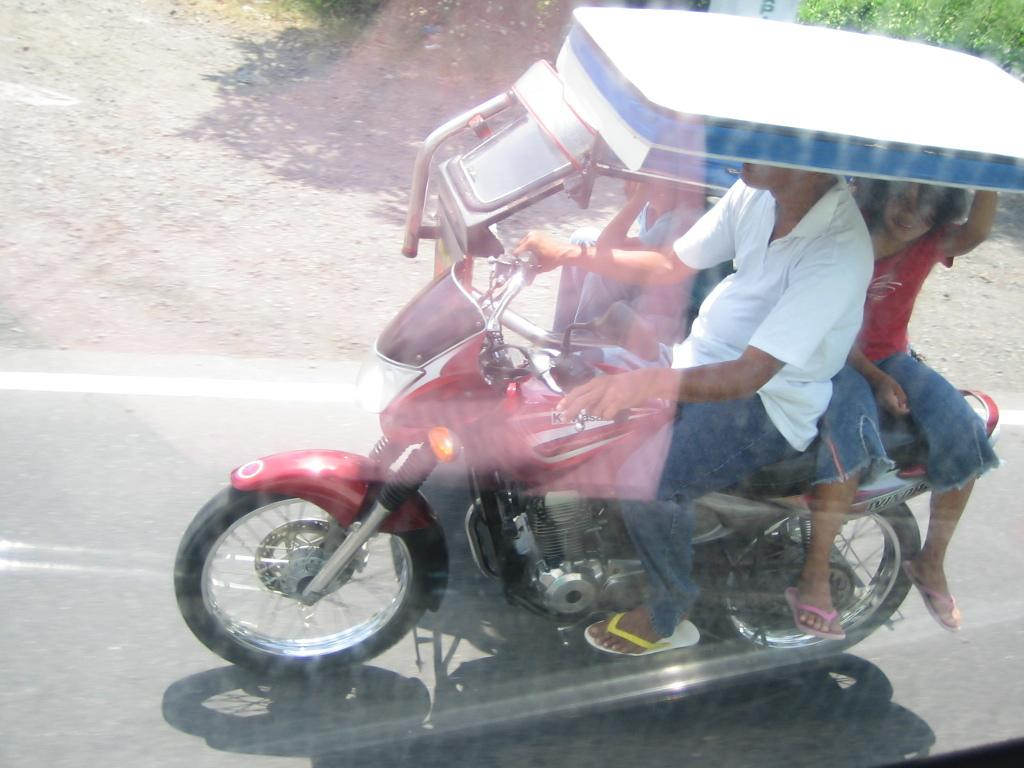Who is present in the image? There are people in the image. What are the people doing in the image? The people are on bikes. What can be seen in the background of the image? There is a tree visible in the background of the image. How many girls are riding snails in the image? There are no girls or snails present in the image; the people are riding bikes. 